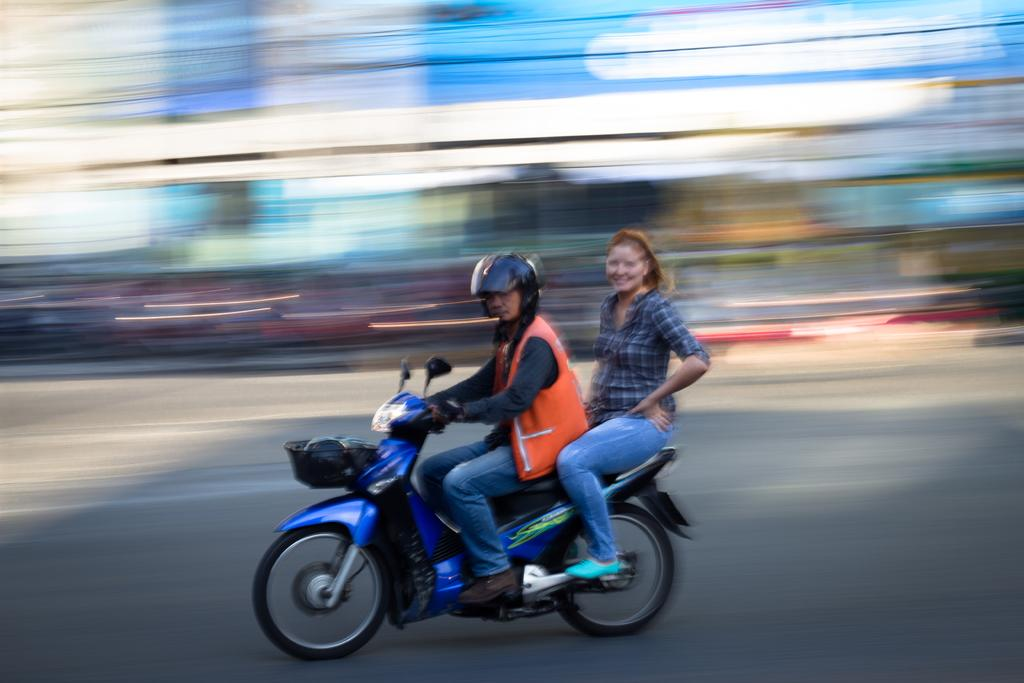What is the man in the image doing? The man is driving a motorcycle. What safety precaution is the man taking while driving the motorcycle? The man is wearing a helmet. What color is the jacket the man is wearing? The man is wearing an orange color jacket. What color are the jeans the man is wearing? The man is wearing blue color jeans. Who is sitting behind the man on the motorcycle? A woman is sitting behind the man on the motorcycle. What is the expression on the woman's face? The woman is smiling. What is the condition of the jail in the image? There is no jail present in the image. What act is the man performing on the motorcycle? The man is simply driving the motorcycle, and no specific act is being performed. 